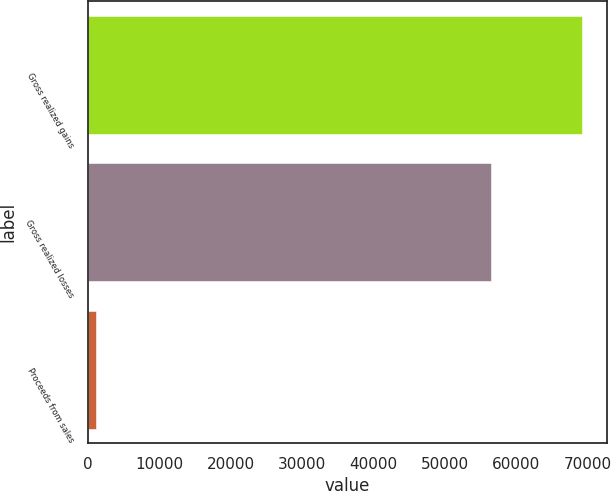<chart> <loc_0><loc_0><loc_500><loc_500><bar_chart><fcel>Gross realized gains<fcel>Gross realized losses<fcel>Proceeds from sales<nl><fcel>69249<fcel>56499<fcel>1138<nl></chart> 